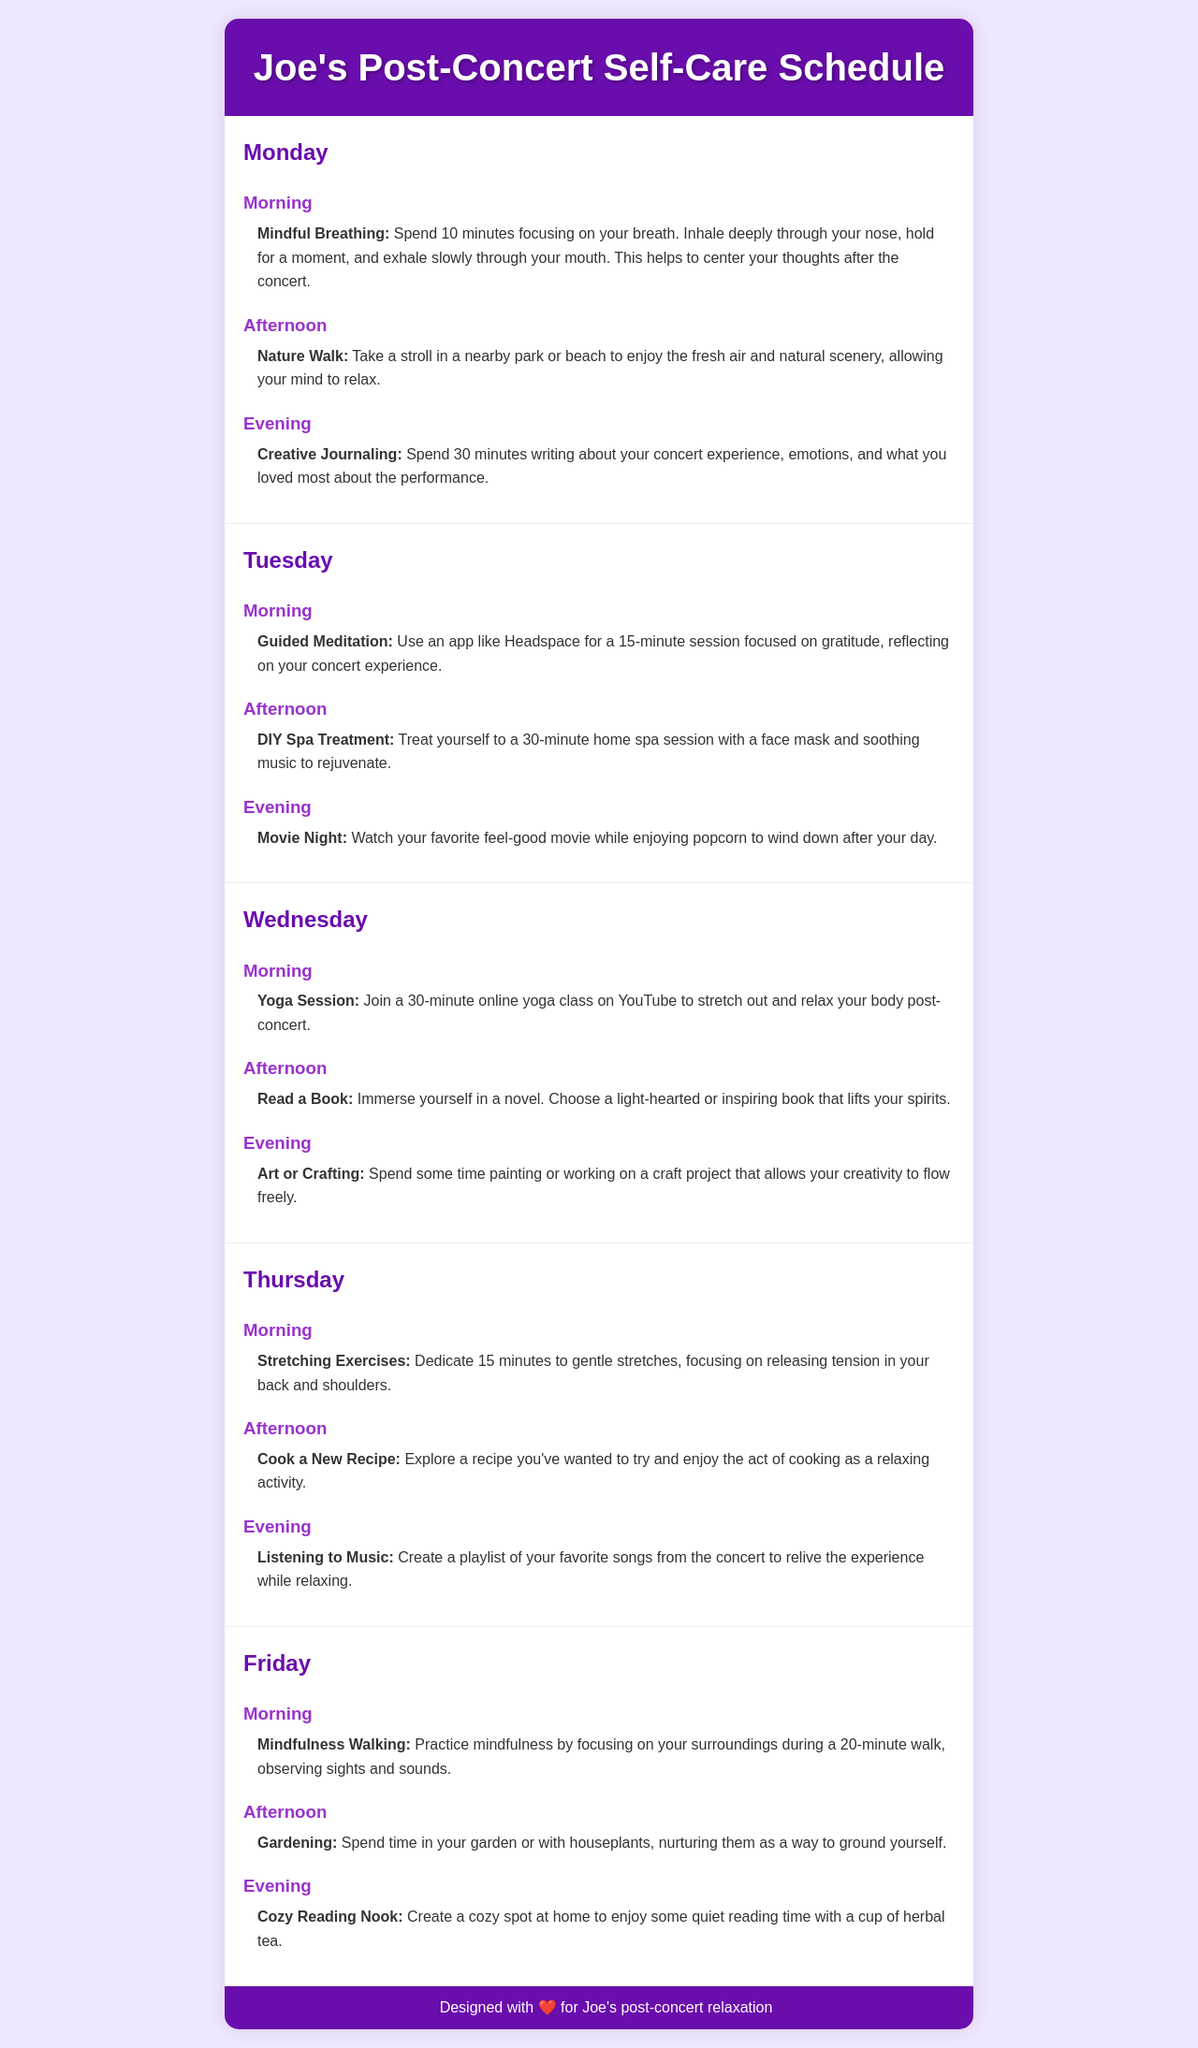What is the title of the schedule? The title of the schedule is indicated at the top of the document as "Joe's Post-Concert Self-Care Schedule."
Answer: Joe's Post-Concert Self-Care Schedule How long is the guided meditation session? The guided meditation session is mentioned to be a 15-minute session found in the Tuesday morning slot.
Answer: 15 minutes What activity is scheduled for Wednesday evening? The Wednesday evening activity is specified as "Art or Crafting."
Answer: Art or Crafting Which day's afternoon activity involves cooking? The Thursday afternoon activity mentions cooking a new recipe as a relaxing activity.
Answer: Thursday What type of exercises are scheduled for Friday morning? The Friday morning activity consists of "Mindfulness Walking."
Answer: Mindfulness Walking On which day is creative journaling scheduled? Creative journaling is specified for the evening of Monday.
Answer: Monday How many minutes are dedicated to mindful breathing? Mindful breathing is stated to take 10 minutes, according to the Monday morning slot.
Answer: 10 minutes Which leisure activity is planned for Tuesday evening? The Tuesday evening activity is said to be "Movie Night."
Answer: Movie Night What is suggested for self-care on Thursday evening? The Thursday evening activity recommends "Listening to Music."
Answer: Listening to Music 